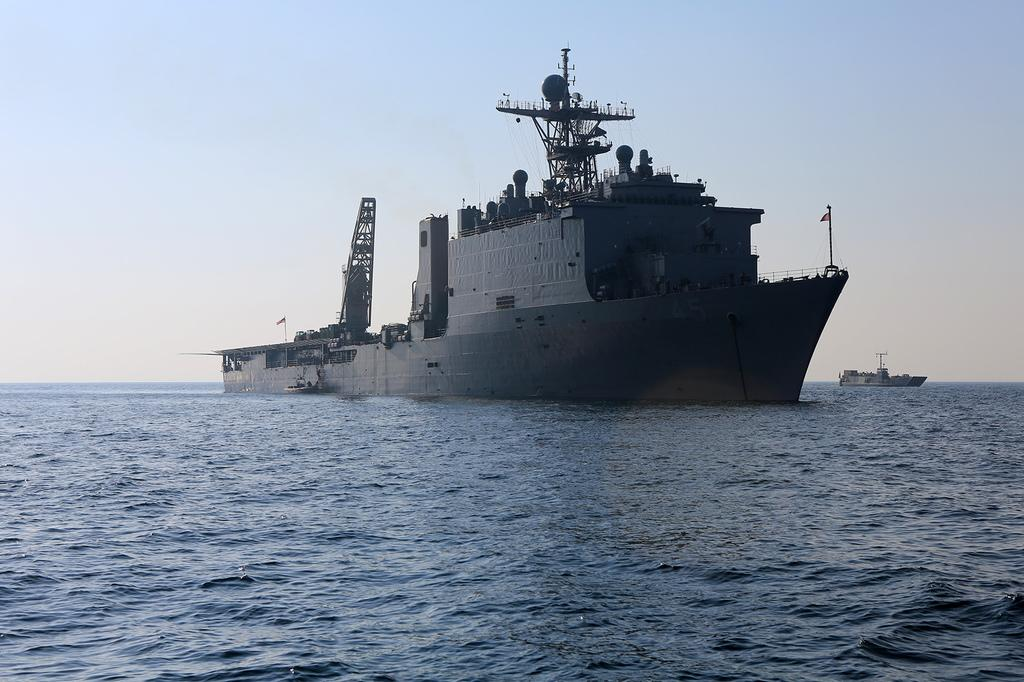What can be seen in the image related to transportation? There are two ships in the image. Where are the ships located? The ships are on the water. What feature can be seen on the ships? There are poles on the ships. What is visible in the background of the image? The sky is visible behind the ships. How many balloons are tied to the poles on the ships? There are no balloons present in the image; it only features two ships with poles. What type of zipper can be seen on the ships? There are no zippers present on the ships in the image. 